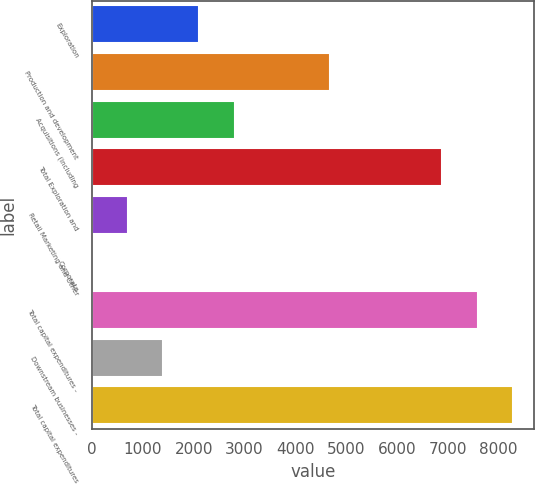Convert chart to OTSL. <chart><loc_0><loc_0><loc_500><loc_500><bar_chart><fcel>Exploration<fcel>Production and development<fcel>Acquisitions (including<fcel>Total Exploration and<fcel>Retail Marketing and Other<fcel>Corporate<fcel>Total capital expenditures -<fcel>Downstream businesses -<fcel>Total capital expenditures<nl><fcel>2103.9<fcel>4673<fcel>2804.2<fcel>6888<fcel>703.3<fcel>3<fcel>7588.3<fcel>1403.6<fcel>8288.6<nl></chart> 